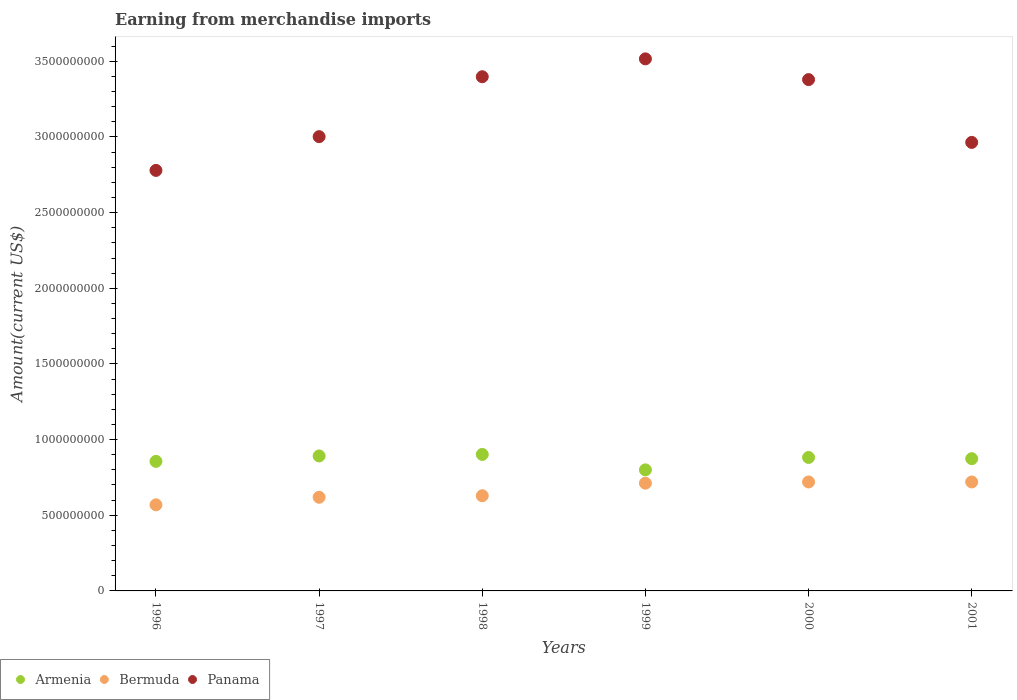How many different coloured dotlines are there?
Your answer should be compact. 3. What is the amount earned from merchandise imports in Armenia in 1997?
Provide a succinct answer. 8.92e+08. Across all years, what is the maximum amount earned from merchandise imports in Armenia?
Give a very brief answer. 9.02e+08. Across all years, what is the minimum amount earned from merchandise imports in Panama?
Keep it short and to the point. 2.78e+09. In which year was the amount earned from merchandise imports in Bermuda minimum?
Provide a short and direct response. 1996. What is the total amount earned from merchandise imports in Armenia in the graph?
Keep it short and to the point. 5.21e+09. What is the difference between the amount earned from merchandise imports in Bermuda in 1997 and that in 1999?
Keep it short and to the point. -9.30e+07. What is the difference between the amount earned from merchandise imports in Bermuda in 1998 and the amount earned from merchandise imports in Armenia in 1996?
Make the answer very short. -2.27e+08. What is the average amount earned from merchandise imports in Bermuda per year?
Your answer should be very brief. 6.62e+08. In the year 2000, what is the difference between the amount earned from merchandise imports in Armenia and amount earned from merchandise imports in Panama?
Keep it short and to the point. -2.50e+09. What is the ratio of the amount earned from merchandise imports in Bermuda in 1997 to that in 2001?
Ensure brevity in your answer.  0.86. Is the difference between the amount earned from merchandise imports in Armenia in 1997 and 1998 greater than the difference between the amount earned from merchandise imports in Panama in 1997 and 1998?
Your answer should be compact. Yes. What is the difference between the highest and the second highest amount earned from merchandise imports in Armenia?
Provide a succinct answer. 1.00e+07. What is the difference between the highest and the lowest amount earned from merchandise imports in Armenia?
Provide a short and direct response. 1.02e+08. Does the amount earned from merchandise imports in Panama monotonically increase over the years?
Your answer should be compact. No. Is the amount earned from merchandise imports in Panama strictly greater than the amount earned from merchandise imports in Bermuda over the years?
Your answer should be compact. Yes. How many dotlines are there?
Offer a very short reply. 3. How many years are there in the graph?
Give a very brief answer. 6. What is the difference between two consecutive major ticks on the Y-axis?
Keep it short and to the point. 5.00e+08. Does the graph contain any zero values?
Your response must be concise. No. Where does the legend appear in the graph?
Keep it short and to the point. Bottom left. What is the title of the graph?
Ensure brevity in your answer.  Earning from merchandise imports. Does "High income: nonOECD" appear as one of the legend labels in the graph?
Offer a terse response. No. What is the label or title of the X-axis?
Give a very brief answer. Years. What is the label or title of the Y-axis?
Keep it short and to the point. Amount(current US$). What is the Amount(current US$) of Armenia in 1996?
Keep it short and to the point. 8.56e+08. What is the Amount(current US$) in Bermuda in 1996?
Offer a terse response. 5.69e+08. What is the Amount(current US$) in Panama in 1996?
Ensure brevity in your answer.  2.78e+09. What is the Amount(current US$) in Armenia in 1997?
Your answer should be very brief. 8.92e+08. What is the Amount(current US$) in Bermuda in 1997?
Make the answer very short. 6.19e+08. What is the Amount(current US$) of Panama in 1997?
Your answer should be compact. 3.00e+09. What is the Amount(current US$) in Armenia in 1998?
Provide a succinct answer. 9.02e+08. What is the Amount(current US$) in Bermuda in 1998?
Offer a terse response. 6.29e+08. What is the Amount(current US$) in Panama in 1998?
Make the answer very short. 3.40e+09. What is the Amount(current US$) in Armenia in 1999?
Offer a very short reply. 8.00e+08. What is the Amount(current US$) in Bermuda in 1999?
Your answer should be very brief. 7.12e+08. What is the Amount(current US$) in Panama in 1999?
Give a very brief answer. 3.52e+09. What is the Amount(current US$) in Armenia in 2000?
Provide a succinct answer. 8.82e+08. What is the Amount(current US$) of Bermuda in 2000?
Ensure brevity in your answer.  7.20e+08. What is the Amount(current US$) of Panama in 2000?
Your answer should be compact. 3.38e+09. What is the Amount(current US$) of Armenia in 2001?
Provide a short and direct response. 8.74e+08. What is the Amount(current US$) of Bermuda in 2001?
Keep it short and to the point. 7.20e+08. What is the Amount(current US$) of Panama in 2001?
Give a very brief answer. 2.96e+09. Across all years, what is the maximum Amount(current US$) of Armenia?
Give a very brief answer. 9.02e+08. Across all years, what is the maximum Amount(current US$) of Bermuda?
Provide a succinct answer. 7.20e+08. Across all years, what is the maximum Amount(current US$) of Panama?
Provide a succinct answer. 3.52e+09. Across all years, what is the minimum Amount(current US$) of Armenia?
Your answer should be compact. 8.00e+08. Across all years, what is the minimum Amount(current US$) of Bermuda?
Offer a very short reply. 5.69e+08. Across all years, what is the minimum Amount(current US$) in Panama?
Keep it short and to the point. 2.78e+09. What is the total Amount(current US$) in Armenia in the graph?
Your answer should be compact. 5.21e+09. What is the total Amount(current US$) of Bermuda in the graph?
Ensure brevity in your answer.  3.97e+09. What is the total Amount(current US$) in Panama in the graph?
Ensure brevity in your answer.  1.90e+1. What is the difference between the Amount(current US$) in Armenia in 1996 and that in 1997?
Offer a very short reply. -3.60e+07. What is the difference between the Amount(current US$) in Bermuda in 1996 and that in 1997?
Give a very brief answer. -5.00e+07. What is the difference between the Amount(current US$) in Panama in 1996 and that in 1997?
Provide a succinct answer. -2.23e+08. What is the difference between the Amount(current US$) in Armenia in 1996 and that in 1998?
Offer a terse response. -4.60e+07. What is the difference between the Amount(current US$) of Bermuda in 1996 and that in 1998?
Give a very brief answer. -6.00e+07. What is the difference between the Amount(current US$) in Panama in 1996 and that in 1998?
Provide a succinct answer. -6.19e+08. What is the difference between the Amount(current US$) in Armenia in 1996 and that in 1999?
Your answer should be very brief. 5.60e+07. What is the difference between the Amount(current US$) in Bermuda in 1996 and that in 1999?
Give a very brief answer. -1.43e+08. What is the difference between the Amount(current US$) of Panama in 1996 and that in 1999?
Provide a short and direct response. -7.37e+08. What is the difference between the Amount(current US$) in Armenia in 1996 and that in 2000?
Your answer should be compact. -2.60e+07. What is the difference between the Amount(current US$) of Bermuda in 1996 and that in 2000?
Your answer should be compact. -1.51e+08. What is the difference between the Amount(current US$) in Panama in 1996 and that in 2000?
Give a very brief answer. -6.00e+08. What is the difference between the Amount(current US$) in Armenia in 1996 and that in 2001?
Make the answer very short. -1.80e+07. What is the difference between the Amount(current US$) in Bermuda in 1996 and that in 2001?
Keep it short and to the point. -1.51e+08. What is the difference between the Amount(current US$) of Panama in 1996 and that in 2001?
Your answer should be compact. -1.85e+08. What is the difference between the Amount(current US$) in Armenia in 1997 and that in 1998?
Keep it short and to the point. -1.00e+07. What is the difference between the Amount(current US$) in Bermuda in 1997 and that in 1998?
Make the answer very short. -1.00e+07. What is the difference between the Amount(current US$) in Panama in 1997 and that in 1998?
Give a very brief answer. -3.96e+08. What is the difference between the Amount(current US$) of Armenia in 1997 and that in 1999?
Make the answer very short. 9.20e+07. What is the difference between the Amount(current US$) of Bermuda in 1997 and that in 1999?
Make the answer very short. -9.30e+07. What is the difference between the Amount(current US$) of Panama in 1997 and that in 1999?
Keep it short and to the point. -5.14e+08. What is the difference between the Amount(current US$) in Armenia in 1997 and that in 2000?
Give a very brief answer. 1.00e+07. What is the difference between the Amount(current US$) of Bermuda in 1997 and that in 2000?
Offer a terse response. -1.01e+08. What is the difference between the Amount(current US$) of Panama in 1997 and that in 2000?
Your answer should be very brief. -3.77e+08. What is the difference between the Amount(current US$) in Armenia in 1997 and that in 2001?
Ensure brevity in your answer.  1.80e+07. What is the difference between the Amount(current US$) in Bermuda in 1997 and that in 2001?
Your response must be concise. -1.01e+08. What is the difference between the Amount(current US$) in Panama in 1997 and that in 2001?
Provide a short and direct response. 3.80e+07. What is the difference between the Amount(current US$) in Armenia in 1998 and that in 1999?
Offer a terse response. 1.02e+08. What is the difference between the Amount(current US$) of Bermuda in 1998 and that in 1999?
Offer a very short reply. -8.30e+07. What is the difference between the Amount(current US$) in Panama in 1998 and that in 1999?
Keep it short and to the point. -1.18e+08. What is the difference between the Amount(current US$) of Armenia in 1998 and that in 2000?
Your answer should be very brief. 2.00e+07. What is the difference between the Amount(current US$) of Bermuda in 1998 and that in 2000?
Offer a terse response. -9.10e+07. What is the difference between the Amount(current US$) in Panama in 1998 and that in 2000?
Give a very brief answer. 1.90e+07. What is the difference between the Amount(current US$) in Armenia in 1998 and that in 2001?
Your answer should be very brief. 2.80e+07. What is the difference between the Amount(current US$) in Bermuda in 1998 and that in 2001?
Offer a very short reply. -9.10e+07. What is the difference between the Amount(current US$) of Panama in 1998 and that in 2001?
Your answer should be very brief. 4.34e+08. What is the difference between the Amount(current US$) of Armenia in 1999 and that in 2000?
Give a very brief answer. -8.20e+07. What is the difference between the Amount(current US$) of Bermuda in 1999 and that in 2000?
Provide a succinct answer. -8.00e+06. What is the difference between the Amount(current US$) in Panama in 1999 and that in 2000?
Keep it short and to the point. 1.37e+08. What is the difference between the Amount(current US$) of Armenia in 1999 and that in 2001?
Keep it short and to the point. -7.40e+07. What is the difference between the Amount(current US$) of Bermuda in 1999 and that in 2001?
Give a very brief answer. -8.00e+06. What is the difference between the Amount(current US$) in Panama in 1999 and that in 2001?
Your response must be concise. 5.52e+08. What is the difference between the Amount(current US$) of Armenia in 2000 and that in 2001?
Your response must be concise. 8.00e+06. What is the difference between the Amount(current US$) in Bermuda in 2000 and that in 2001?
Make the answer very short. 0. What is the difference between the Amount(current US$) of Panama in 2000 and that in 2001?
Provide a short and direct response. 4.15e+08. What is the difference between the Amount(current US$) of Armenia in 1996 and the Amount(current US$) of Bermuda in 1997?
Your answer should be compact. 2.37e+08. What is the difference between the Amount(current US$) in Armenia in 1996 and the Amount(current US$) in Panama in 1997?
Offer a very short reply. -2.15e+09. What is the difference between the Amount(current US$) of Bermuda in 1996 and the Amount(current US$) of Panama in 1997?
Offer a very short reply. -2.43e+09. What is the difference between the Amount(current US$) of Armenia in 1996 and the Amount(current US$) of Bermuda in 1998?
Provide a succinct answer. 2.27e+08. What is the difference between the Amount(current US$) of Armenia in 1996 and the Amount(current US$) of Panama in 1998?
Give a very brief answer. -2.54e+09. What is the difference between the Amount(current US$) of Bermuda in 1996 and the Amount(current US$) of Panama in 1998?
Ensure brevity in your answer.  -2.83e+09. What is the difference between the Amount(current US$) in Armenia in 1996 and the Amount(current US$) in Bermuda in 1999?
Your response must be concise. 1.44e+08. What is the difference between the Amount(current US$) in Armenia in 1996 and the Amount(current US$) in Panama in 1999?
Ensure brevity in your answer.  -2.66e+09. What is the difference between the Amount(current US$) of Bermuda in 1996 and the Amount(current US$) of Panama in 1999?
Keep it short and to the point. -2.95e+09. What is the difference between the Amount(current US$) in Armenia in 1996 and the Amount(current US$) in Bermuda in 2000?
Your response must be concise. 1.36e+08. What is the difference between the Amount(current US$) of Armenia in 1996 and the Amount(current US$) of Panama in 2000?
Ensure brevity in your answer.  -2.52e+09. What is the difference between the Amount(current US$) of Bermuda in 1996 and the Amount(current US$) of Panama in 2000?
Your answer should be compact. -2.81e+09. What is the difference between the Amount(current US$) of Armenia in 1996 and the Amount(current US$) of Bermuda in 2001?
Offer a terse response. 1.36e+08. What is the difference between the Amount(current US$) in Armenia in 1996 and the Amount(current US$) in Panama in 2001?
Provide a succinct answer. -2.11e+09. What is the difference between the Amount(current US$) in Bermuda in 1996 and the Amount(current US$) in Panama in 2001?
Provide a short and direct response. -2.40e+09. What is the difference between the Amount(current US$) in Armenia in 1997 and the Amount(current US$) in Bermuda in 1998?
Provide a short and direct response. 2.63e+08. What is the difference between the Amount(current US$) in Armenia in 1997 and the Amount(current US$) in Panama in 1998?
Offer a terse response. -2.51e+09. What is the difference between the Amount(current US$) in Bermuda in 1997 and the Amount(current US$) in Panama in 1998?
Your answer should be compact. -2.78e+09. What is the difference between the Amount(current US$) of Armenia in 1997 and the Amount(current US$) of Bermuda in 1999?
Provide a short and direct response. 1.80e+08. What is the difference between the Amount(current US$) of Armenia in 1997 and the Amount(current US$) of Panama in 1999?
Offer a very short reply. -2.62e+09. What is the difference between the Amount(current US$) in Bermuda in 1997 and the Amount(current US$) in Panama in 1999?
Your response must be concise. -2.90e+09. What is the difference between the Amount(current US$) of Armenia in 1997 and the Amount(current US$) of Bermuda in 2000?
Your response must be concise. 1.72e+08. What is the difference between the Amount(current US$) of Armenia in 1997 and the Amount(current US$) of Panama in 2000?
Provide a succinct answer. -2.49e+09. What is the difference between the Amount(current US$) of Bermuda in 1997 and the Amount(current US$) of Panama in 2000?
Keep it short and to the point. -2.76e+09. What is the difference between the Amount(current US$) of Armenia in 1997 and the Amount(current US$) of Bermuda in 2001?
Your response must be concise. 1.72e+08. What is the difference between the Amount(current US$) in Armenia in 1997 and the Amount(current US$) in Panama in 2001?
Offer a terse response. -2.07e+09. What is the difference between the Amount(current US$) of Bermuda in 1997 and the Amount(current US$) of Panama in 2001?
Ensure brevity in your answer.  -2.34e+09. What is the difference between the Amount(current US$) of Armenia in 1998 and the Amount(current US$) of Bermuda in 1999?
Provide a succinct answer. 1.90e+08. What is the difference between the Amount(current US$) in Armenia in 1998 and the Amount(current US$) in Panama in 1999?
Ensure brevity in your answer.  -2.61e+09. What is the difference between the Amount(current US$) in Bermuda in 1998 and the Amount(current US$) in Panama in 1999?
Provide a short and direct response. -2.89e+09. What is the difference between the Amount(current US$) of Armenia in 1998 and the Amount(current US$) of Bermuda in 2000?
Make the answer very short. 1.82e+08. What is the difference between the Amount(current US$) of Armenia in 1998 and the Amount(current US$) of Panama in 2000?
Your response must be concise. -2.48e+09. What is the difference between the Amount(current US$) of Bermuda in 1998 and the Amount(current US$) of Panama in 2000?
Provide a short and direct response. -2.75e+09. What is the difference between the Amount(current US$) of Armenia in 1998 and the Amount(current US$) of Bermuda in 2001?
Offer a terse response. 1.82e+08. What is the difference between the Amount(current US$) in Armenia in 1998 and the Amount(current US$) in Panama in 2001?
Provide a succinct answer. -2.06e+09. What is the difference between the Amount(current US$) of Bermuda in 1998 and the Amount(current US$) of Panama in 2001?
Ensure brevity in your answer.  -2.34e+09. What is the difference between the Amount(current US$) in Armenia in 1999 and the Amount(current US$) in Bermuda in 2000?
Provide a short and direct response. 8.00e+07. What is the difference between the Amount(current US$) of Armenia in 1999 and the Amount(current US$) of Panama in 2000?
Provide a short and direct response. -2.58e+09. What is the difference between the Amount(current US$) of Bermuda in 1999 and the Amount(current US$) of Panama in 2000?
Provide a short and direct response. -2.67e+09. What is the difference between the Amount(current US$) in Armenia in 1999 and the Amount(current US$) in Bermuda in 2001?
Ensure brevity in your answer.  8.00e+07. What is the difference between the Amount(current US$) of Armenia in 1999 and the Amount(current US$) of Panama in 2001?
Provide a short and direct response. -2.16e+09. What is the difference between the Amount(current US$) of Bermuda in 1999 and the Amount(current US$) of Panama in 2001?
Your response must be concise. -2.25e+09. What is the difference between the Amount(current US$) in Armenia in 2000 and the Amount(current US$) in Bermuda in 2001?
Keep it short and to the point. 1.62e+08. What is the difference between the Amount(current US$) of Armenia in 2000 and the Amount(current US$) of Panama in 2001?
Make the answer very short. -2.08e+09. What is the difference between the Amount(current US$) of Bermuda in 2000 and the Amount(current US$) of Panama in 2001?
Your answer should be compact. -2.24e+09. What is the average Amount(current US$) in Armenia per year?
Offer a very short reply. 8.68e+08. What is the average Amount(current US$) in Bermuda per year?
Offer a very short reply. 6.62e+08. What is the average Amount(current US$) in Panama per year?
Your answer should be very brief. 3.17e+09. In the year 1996, what is the difference between the Amount(current US$) of Armenia and Amount(current US$) of Bermuda?
Your response must be concise. 2.87e+08. In the year 1996, what is the difference between the Amount(current US$) of Armenia and Amount(current US$) of Panama?
Ensure brevity in your answer.  -1.92e+09. In the year 1996, what is the difference between the Amount(current US$) of Bermuda and Amount(current US$) of Panama?
Your response must be concise. -2.21e+09. In the year 1997, what is the difference between the Amount(current US$) in Armenia and Amount(current US$) in Bermuda?
Provide a short and direct response. 2.73e+08. In the year 1997, what is the difference between the Amount(current US$) of Armenia and Amount(current US$) of Panama?
Offer a very short reply. -2.11e+09. In the year 1997, what is the difference between the Amount(current US$) of Bermuda and Amount(current US$) of Panama?
Offer a very short reply. -2.38e+09. In the year 1998, what is the difference between the Amount(current US$) of Armenia and Amount(current US$) of Bermuda?
Give a very brief answer. 2.73e+08. In the year 1998, what is the difference between the Amount(current US$) of Armenia and Amount(current US$) of Panama?
Provide a short and direct response. -2.50e+09. In the year 1998, what is the difference between the Amount(current US$) of Bermuda and Amount(current US$) of Panama?
Ensure brevity in your answer.  -2.77e+09. In the year 1999, what is the difference between the Amount(current US$) of Armenia and Amount(current US$) of Bermuda?
Give a very brief answer. 8.80e+07. In the year 1999, what is the difference between the Amount(current US$) in Armenia and Amount(current US$) in Panama?
Offer a terse response. -2.72e+09. In the year 1999, what is the difference between the Amount(current US$) in Bermuda and Amount(current US$) in Panama?
Provide a short and direct response. -2.80e+09. In the year 2000, what is the difference between the Amount(current US$) in Armenia and Amount(current US$) in Bermuda?
Offer a terse response. 1.62e+08. In the year 2000, what is the difference between the Amount(current US$) of Armenia and Amount(current US$) of Panama?
Provide a succinct answer. -2.50e+09. In the year 2000, what is the difference between the Amount(current US$) of Bermuda and Amount(current US$) of Panama?
Offer a very short reply. -2.66e+09. In the year 2001, what is the difference between the Amount(current US$) in Armenia and Amount(current US$) in Bermuda?
Your response must be concise. 1.54e+08. In the year 2001, what is the difference between the Amount(current US$) in Armenia and Amount(current US$) in Panama?
Keep it short and to the point. -2.09e+09. In the year 2001, what is the difference between the Amount(current US$) of Bermuda and Amount(current US$) of Panama?
Your answer should be very brief. -2.24e+09. What is the ratio of the Amount(current US$) of Armenia in 1996 to that in 1997?
Your answer should be very brief. 0.96. What is the ratio of the Amount(current US$) in Bermuda in 1996 to that in 1997?
Your answer should be very brief. 0.92. What is the ratio of the Amount(current US$) of Panama in 1996 to that in 1997?
Keep it short and to the point. 0.93. What is the ratio of the Amount(current US$) in Armenia in 1996 to that in 1998?
Provide a succinct answer. 0.95. What is the ratio of the Amount(current US$) of Bermuda in 1996 to that in 1998?
Offer a terse response. 0.9. What is the ratio of the Amount(current US$) of Panama in 1996 to that in 1998?
Provide a short and direct response. 0.82. What is the ratio of the Amount(current US$) in Armenia in 1996 to that in 1999?
Ensure brevity in your answer.  1.07. What is the ratio of the Amount(current US$) of Bermuda in 1996 to that in 1999?
Ensure brevity in your answer.  0.8. What is the ratio of the Amount(current US$) in Panama in 1996 to that in 1999?
Offer a terse response. 0.79. What is the ratio of the Amount(current US$) of Armenia in 1996 to that in 2000?
Offer a terse response. 0.97. What is the ratio of the Amount(current US$) of Bermuda in 1996 to that in 2000?
Make the answer very short. 0.79. What is the ratio of the Amount(current US$) in Panama in 1996 to that in 2000?
Make the answer very short. 0.82. What is the ratio of the Amount(current US$) of Armenia in 1996 to that in 2001?
Your response must be concise. 0.98. What is the ratio of the Amount(current US$) of Bermuda in 1996 to that in 2001?
Your answer should be compact. 0.79. What is the ratio of the Amount(current US$) of Panama in 1996 to that in 2001?
Your response must be concise. 0.94. What is the ratio of the Amount(current US$) of Armenia in 1997 to that in 1998?
Make the answer very short. 0.99. What is the ratio of the Amount(current US$) in Bermuda in 1997 to that in 1998?
Give a very brief answer. 0.98. What is the ratio of the Amount(current US$) in Panama in 1997 to that in 1998?
Provide a succinct answer. 0.88. What is the ratio of the Amount(current US$) of Armenia in 1997 to that in 1999?
Give a very brief answer. 1.11. What is the ratio of the Amount(current US$) in Bermuda in 1997 to that in 1999?
Provide a succinct answer. 0.87. What is the ratio of the Amount(current US$) in Panama in 1997 to that in 1999?
Offer a very short reply. 0.85. What is the ratio of the Amount(current US$) of Armenia in 1997 to that in 2000?
Your answer should be compact. 1.01. What is the ratio of the Amount(current US$) of Bermuda in 1997 to that in 2000?
Offer a very short reply. 0.86. What is the ratio of the Amount(current US$) of Panama in 1997 to that in 2000?
Provide a succinct answer. 0.89. What is the ratio of the Amount(current US$) in Armenia in 1997 to that in 2001?
Ensure brevity in your answer.  1.02. What is the ratio of the Amount(current US$) in Bermuda in 1997 to that in 2001?
Provide a succinct answer. 0.86. What is the ratio of the Amount(current US$) of Panama in 1997 to that in 2001?
Provide a short and direct response. 1.01. What is the ratio of the Amount(current US$) of Armenia in 1998 to that in 1999?
Give a very brief answer. 1.13. What is the ratio of the Amount(current US$) in Bermuda in 1998 to that in 1999?
Your response must be concise. 0.88. What is the ratio of the Amount(current US$) in Panama in 1998 to that in 1999?
Offer a terse response. 0.97. What is the ratio of the Amount(current US$) of Armenia in 1998 to that in 2000?
Your answer should be very brief. 1.02. What is the ratio of the Amount(current US$) in Bermuda in 1998 to that in 2000?
Provide a succinct answer. 0.87. What is the ratio of the Amount(current US$) of Panama in 1998 to that in 2000?
Your answer should be compact. 1.01. What is the ratio of the Amount(current US$) in Armenia in 1998 to that in 2001?
Offer a very short reply. 1.03. What is the ratio of the Amount(current US$) in Bermuda in 1998 to that in 2001?
Make the answer very short. 0.87. What is the ratio of the Amount(current US$) of Panama in 1998 to that in 2001?
Offer a terse response. 1.15. What is the ratio of the Amount(current US$) of Armenia in 1999 to that in 2000?
Your answer should be compact. 0.91. What is the ratio of the Amount(current US$) of Bermuda in 1999 to that in 2000?
Offer a very short reply. 0.99. What is the ratio of the Amount(current US$) in Panama in 1999 to that in 2000?
Offer a very short reply. 1.04. What is the ratio of the Amount(current US$) of Armenia in 1999 to that in 2001?
Your answer should be compact. 0.92. What is the ratio of the Amount(current US$) of Bermuda in 1999 to that in 2001?
Give a very brief answer. 0.99. What is the ratio of the Amount(current US$) in Panama in 1999 to that in 2001?
Offer a terse response. 1.19. What is the ratio of the Amount(current US$) of Armenia in 2000 to that in 2001?
Your answer should be very brief. 1.01. What is the ratio of the Amount(current US$) in Bermuda in 2000 to that in 2001?
Provide a short and direct response. 1. What is the ratio of the Amount(current US$) of Panama in 2000 to that in 2001?
Ensure brevity in your answer.  1.14. What is the difference between the highest and the second highest Amount(current US$) in Panama?
Provide a short and direct response. 1.18e+08. What is the difference between the highest and the lowest Amount(current US$) of Armenia?
Your response must be concise. 1.02e+08. What is the difference between the highest and the lowest Amount(current US$) of Bermuda?
Your answer should be very brief. 1.51e+08. What is the difference between the highest and the lowest Amount(current US$) of Panama?
Your response must be concise. 7.37e+08. 